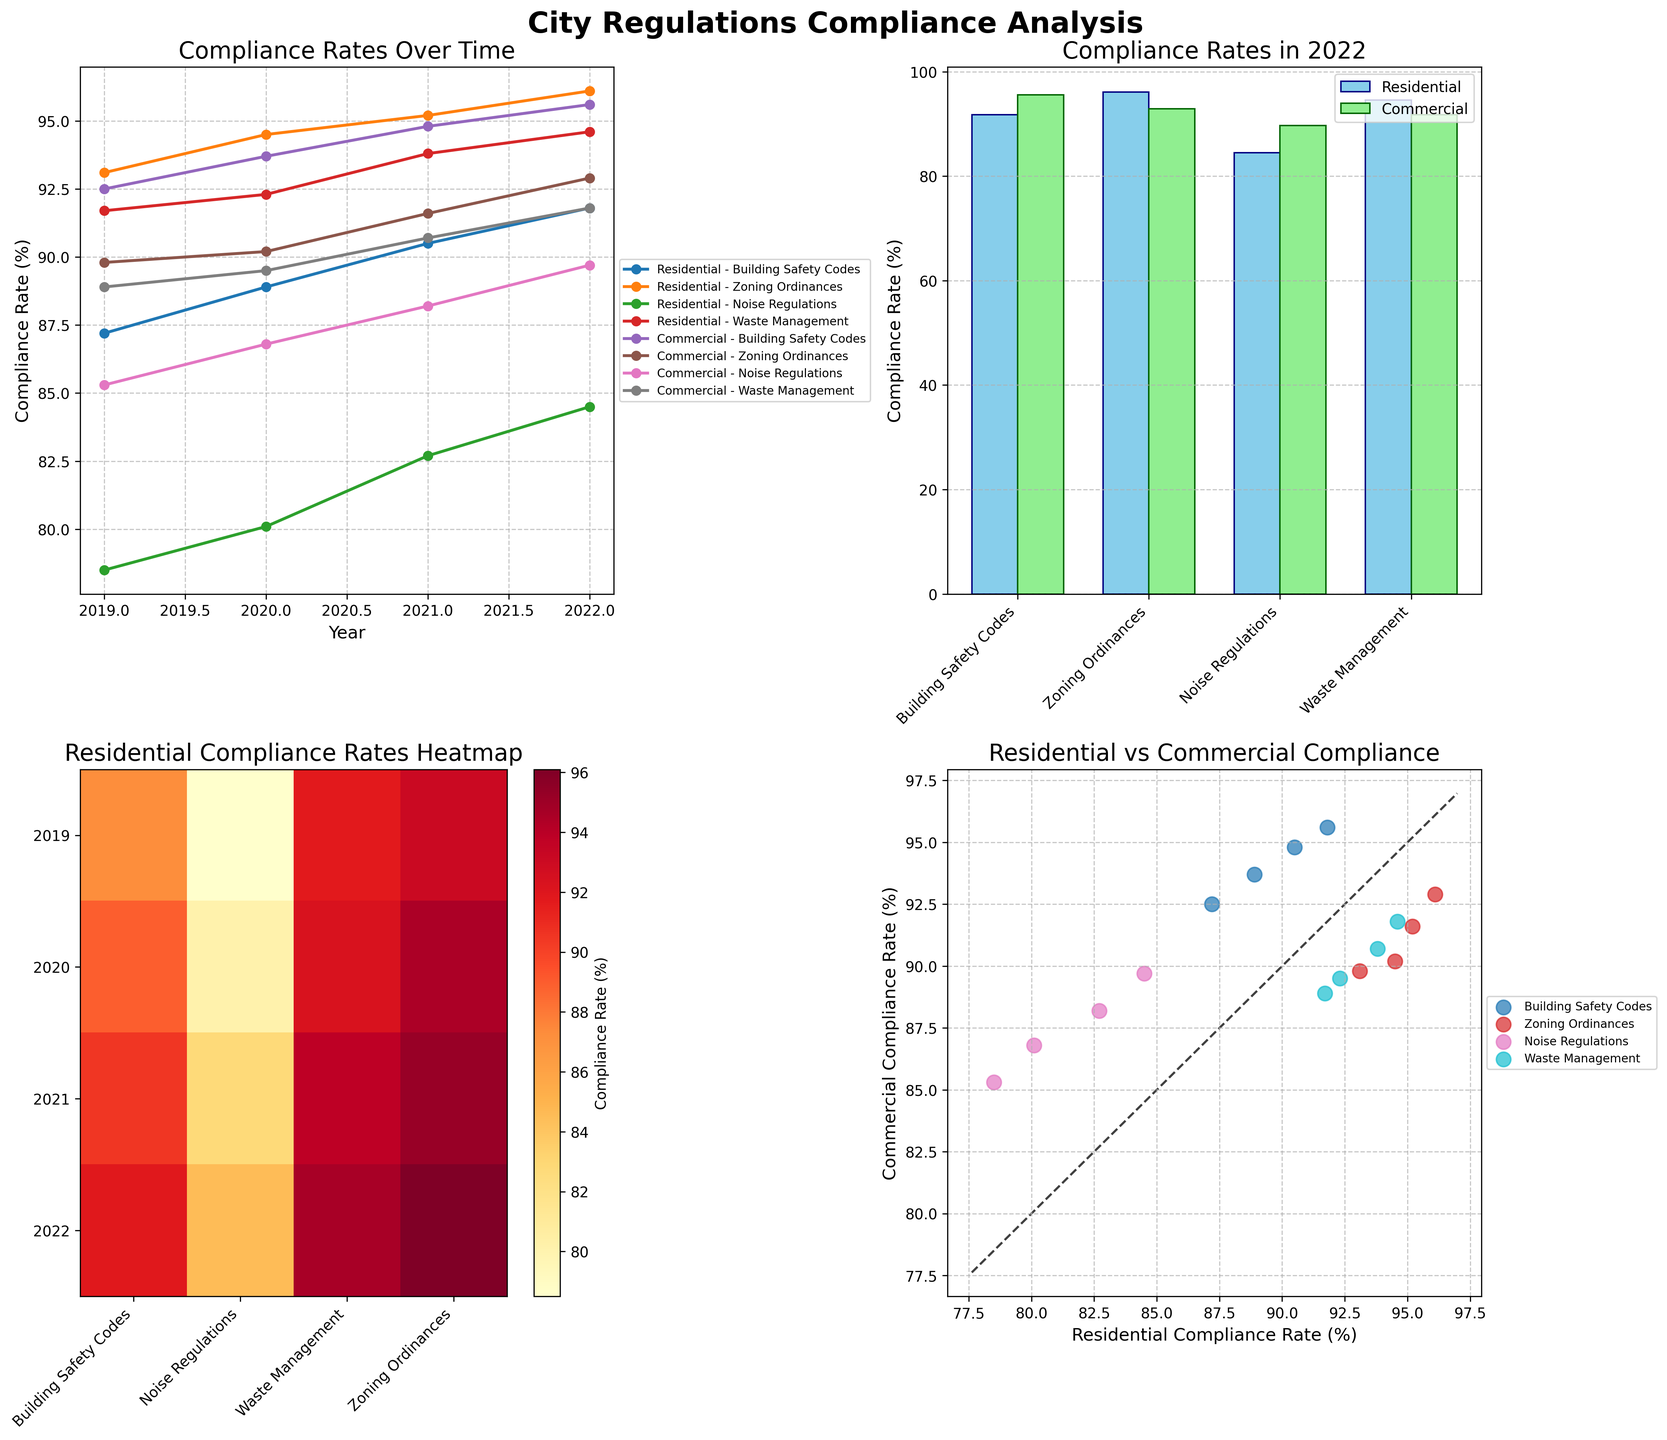How have the residential compliance rates for Noise Regulations changed from 2019 to 2022? The line plot for Residential - Noise Regulations shows an increase in compliance rates over the years. Specifically, they rose from 78.5% in 2019 to 84.5% in 2022.
Answer: Increased from 78.5% to 84.5% Which sector had a higher compliance rate for Building Safety Codes in 2022? Look at the bar plot for the year 2022, the bars for Building Safety Codes show the heights of each sector's compliance rates. The Commercial sector's bar is higher than the Residential sector's, indicating a higher compliance rate.
Answer: Commercial sector What is the average compliance rate for Residential sector Waste Management from 2019 to 2022? According to the line plot, add up the Residential compliance rates for Waste Management for the years 2019 (91.7%), 2020 (92.3%), 2021 (93.8%), and 2022 (94.6%). Then divide by the number of years (4). (91.7 + 92.3 + 93.8 + 94.6) / 4 = 93.1
Answer: 93.1% Can you identify any regulation where the commercial sector consistently outperformed the residential sector from 2019 to 2022? By examining the scatter plot and lines for each regulation over the years, Noise Regulations consistently show higher compliance rates for the Commercial sector compared to the Residential sector.
Answer: Noise Regulations Which regulation shows the largest improvement in Residential compliance rates from 2019 to 2022? Calculate the difference in compliance rates for each regulation between 2019 and 2022 on the line plot. Building Safety Codes show a rise from 87.2% in 2019 to 91.8% in 2022. Zoning Ordinances from 93.1% to 96.1%. Noise Regulations from 78.5% to 84.5%. Waste Management from 91.7% to 94.6%. The largest improvement is Noise Regulations, with an increase of 6%.
Answer: Noise Regulations Which year showed the highest overall residential compliance rates for Building Safety Codes? Checking the Residential - Building Safety Codes line in the plot, the highest point occurs in 2022, with a compliance rate of 91.8%.
Answer: 2022 How does the 2022 residential compliance rate for Zoning Ordinances compare to the commercial compliance rate in the same year? Refer to the bar plot for the year 2022. For Zoning Ordinances, the Residential compliance rate is 96.1%, while the Commercial compliance rate is 92.9%. The Residential rate is higher.
Answer: Residential is higher Regarding the heatmap, which year had the lowest residential compliance rates across all regulations? Look at the colors in the heatmap and compare the shading for each year. 2019 generally has the darker shades (indicating lower compliance rates) across multiple regulations compared to other years.
Answer: 2019 In the scatter plot, are there any Residential compliance rates that are equal to Commercial compliance rates for the same regulation? Inspect each point in the scatter plot, which shows Residential rates on the x-axis and Commercial rates on the y-axis. There are no points lying exactly on the line y = x, so no rates are exactly equal.
Answer: No 